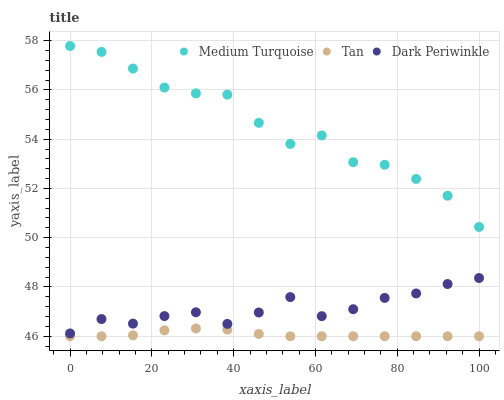Does Tan have the minimum area under the curve?
Answer yes or no. Yes. Does Medium Turquoise have the maximum area under the curve?
Answer yes or no. Yes. Does Dark Periwinkle have the minimum area under the curve?
Answer yes or no. No. Does Dark Periwinkle have the maximum area under the curve?
Answer yes or no. No. Is Tan the smoothest?
Answer yes or no. Yes. Is Medium Turquoise the roughest?
Answer yes or no. Yes. Is Dark Periwinkle the smoothest?
Answer yes or no. No. Is Dark Periwinkle the roughest?
Answer yes or no. No. Does Tan have the lowest value?
Answer yes or no. Yes. Does Dark Periwinkle have the lowest value?
Answer yes or no. No. Does Medium Turquoise have the highest value?
Answer yes or no. Yes. Does Dark Periwinkle have the highest value?
Answer yes or no. No. Is Tan less than Medium Turquoise?
Answer yes or no. Yes. Is Medium Turquoise greater than Dark Periwinkle?
Answer yes or no. Yes. Does Tan intersect Medium Turquoise?
Answer yes or no. No. 